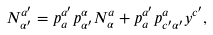<formula> <loc_0><loc_0><loc_500><loc_500>N ^ { a ^ { \prime } } _ { \alpha ^ { \prime } } = p ^ { a ^ { \prime } } _ { a } p ^ { \alpha } _ { \alpha ^ { \prime } } N ^ { a } _ { \alpha } + p ^ { a ^ { \prime } } _ { a } p ^ { a } _ { c ^ { \prime } \alpha ^ { \prime } } y ^ { c ^ { \prime } } ,</formula> 